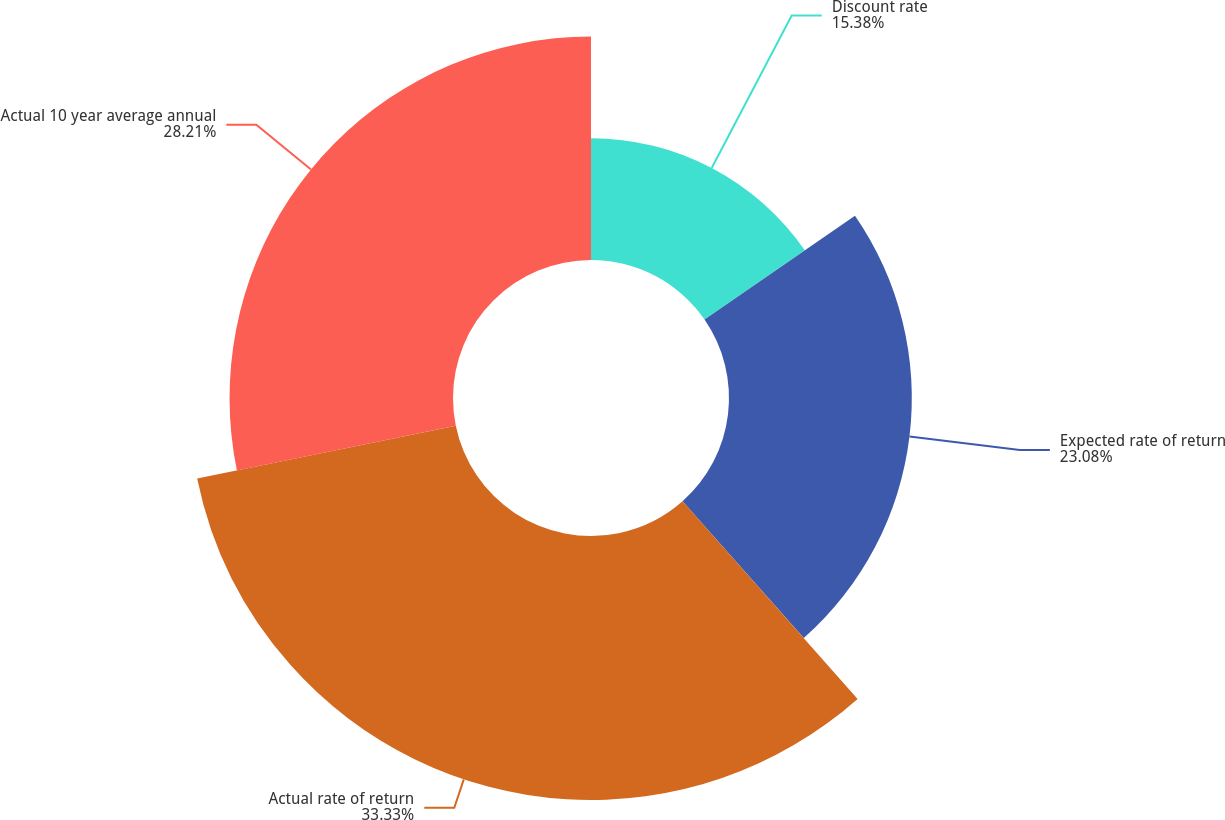<chart> <loc_0><loc_0><loc_500><loc_500><pie_chart><fcel>Discount rate<fcel>Expected rate of return<fcel>Actual rate of return<fcel>Actual 10 year average annual<nl><fcel>15.38%<fcel>23.08%<fcel>33.33%<fcel>28.21%<nl></chart> 